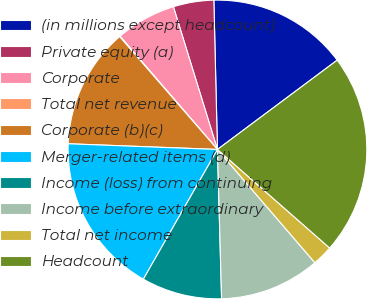Convert chart. <chart><loc_0><loc_0><loc_500><loc_500><pie_chart><fcel>(in millions except headcount)<fcel>Private equity (a)<fcel>Corporate<fcel>Total net revenue<fcel>Corporate (b)(c)<fcel>Merger-related items (d)<fcel>Income (loss) from continuing<fcel>Income before extraordinary<fcel>Total net income<fcel>Headcount<nl><fcel>15.18%<fcel>4.38%<fcel>6.54%<fcel>0.06%<fcel>13.02%<fcel>17.34%<fcel>8.7%<fcel>10.86%<fcel>2.22%<fcel>21.66%<nl></chart> 